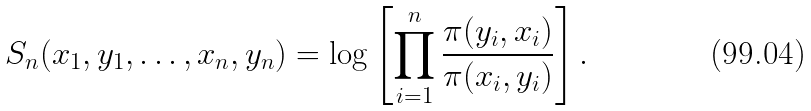<formula> <loc_0><loc_0><loc_500><loc_500>S _ { n } ( x _ { 1 } , y _ { 1 } , \dots , x _ { n } , y _ { n } ) = \log \left [ \prod _ { i = 1 } ^ { n } \frac { \pi ( y _ { i } , x _ { i } ) } { \pi ( x _ { i } , y _ { i } ) } \right ] .</formula> 